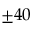<formula> <loc_0><loc_0><loc_500><loc_500>\pm 4 0</formula> 